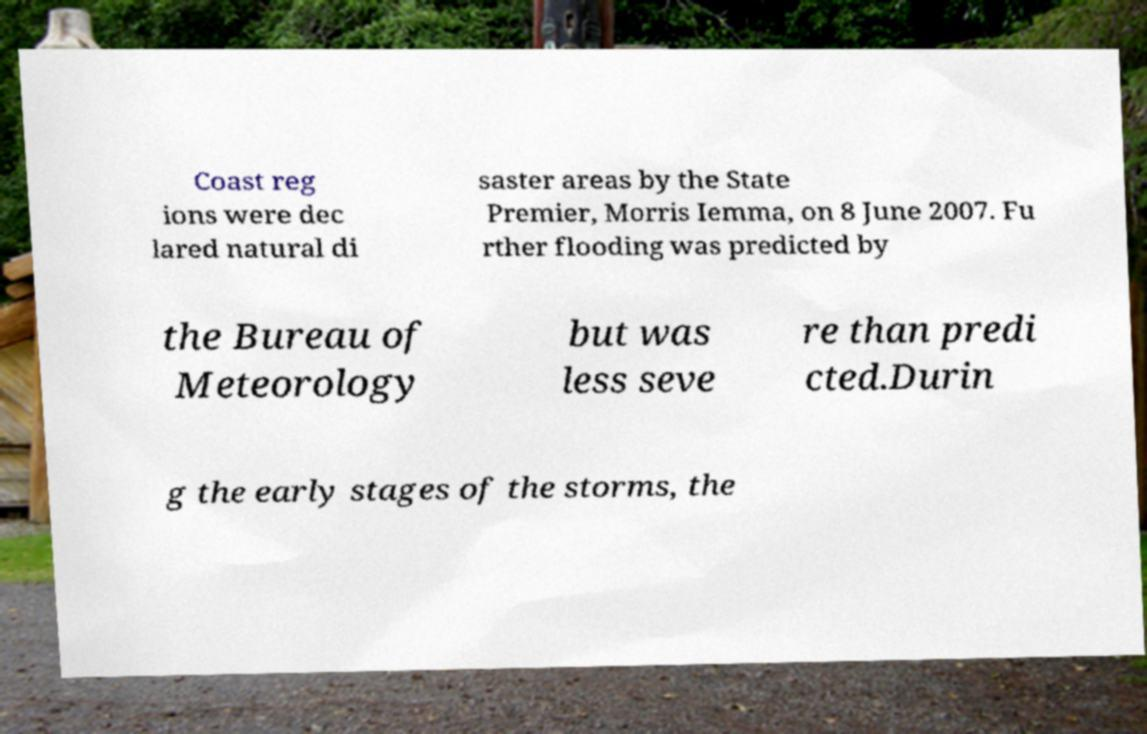Can you read and provide the text displayed in the image?This photo seems to have some interesting text. Can you extract and type it out for me? Coast reg ions were dec lared natural di saster areas by the State Premier, Morris Iemma, on 8 June 2007. Fu rther flooding was predicted by the Bureau of Meteorology but was less seve re than predi cted.Durin g the early stages of the storms, the 